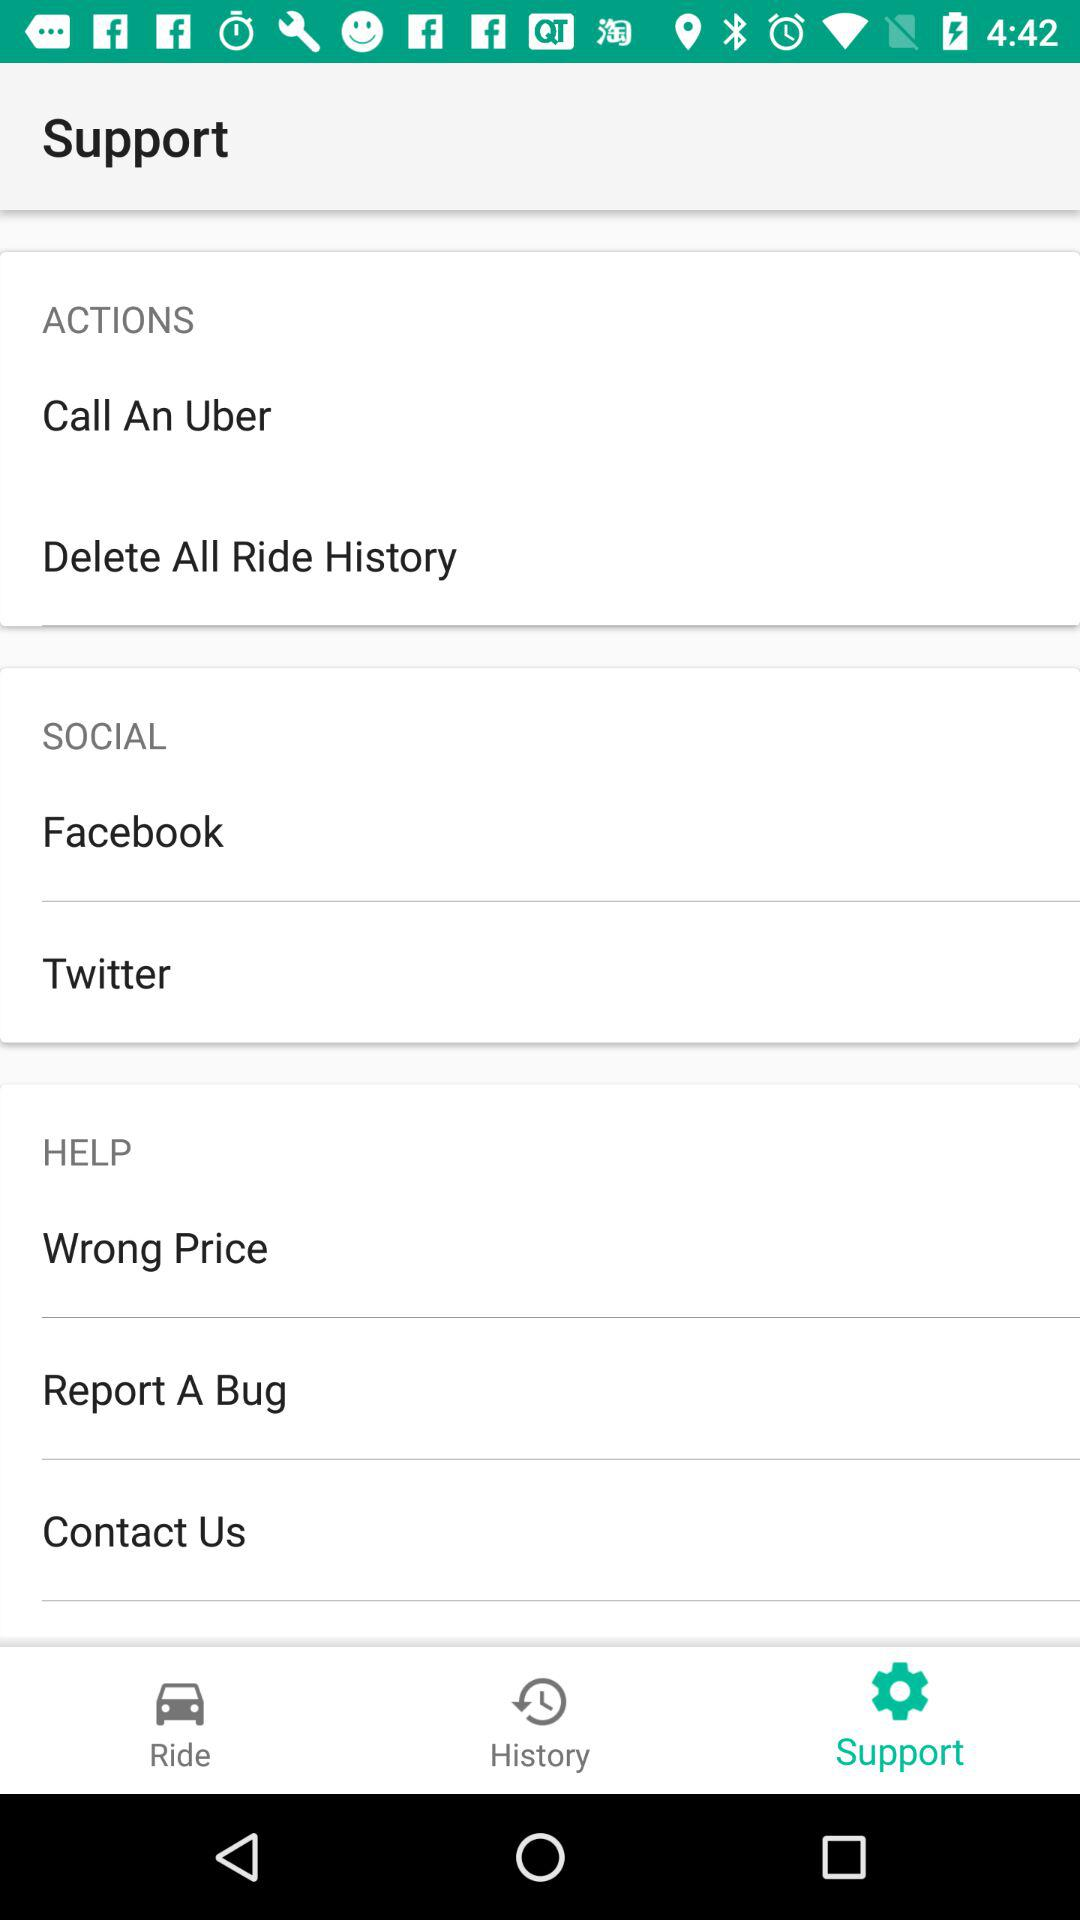Which tab has been selected? The tab that has been selected is "Support". 